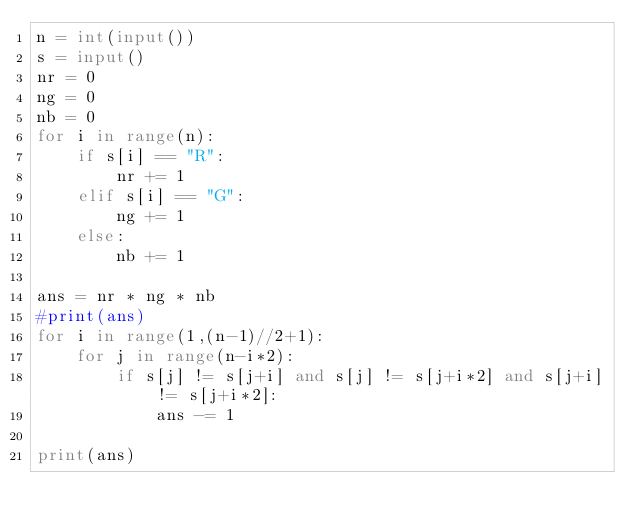Convert code to text. <code><loc_0><loc_0><loc_500><loc_500><_Python_>n = int(input())
s = input()
nr = 0
ng = 0
nb = 0
for i in range(n):
    if s[i] == "R":
        nr += 1
    elif s[i] == "G":
        ng += 1
    else:
        nb += 1
        
ans = nr * ng * nb
#print(ans)
for i in range(1,(n-1)//2+1):
    for j in range(n-i*2):
        if s[j] != s[j+i] and s[j] != s[j+i*2] and s[j+i] != s[j+i*2]:
            ans -= 1
            
print(ans)</code> 